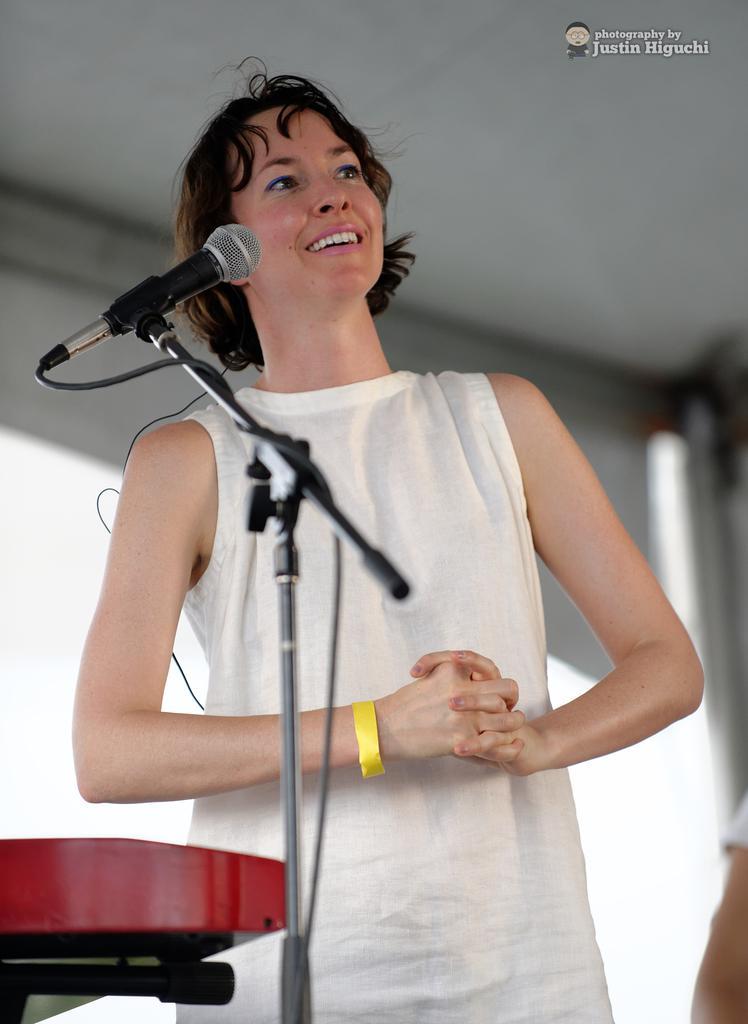Can you describe this image briefly? In this image we can see a person standing near the microphone and there is a red color object. And we can see a blur background. Right side, we can see a text written on the poster. 